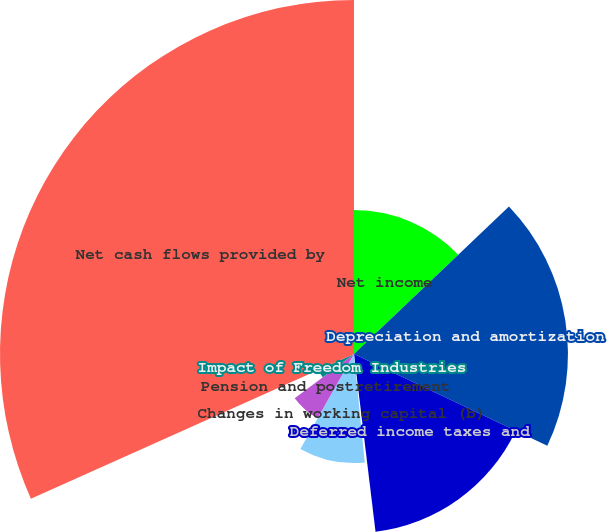Convert chart. <chart><loc_0><loc_0><loc_500><loc_500><pie_chart><fcel>Net income<fcel>Depreciation and amortization<fcel>Deferred income taxes and<fcel>Other non-cash activities (a)<fcel>Changes in working capital (b)<fcel>Pension and postretirement<fcel>Impact of Freedom Industries<fcel>Net cash flows provided by<nl><fcel>12.89%<fcel>19.16%<fcel>16.03%<fcel>0.35%<fcel>9.76%<fcel>6.62%<fcel>3.49%<fcel>31.7%<nl></chart> 